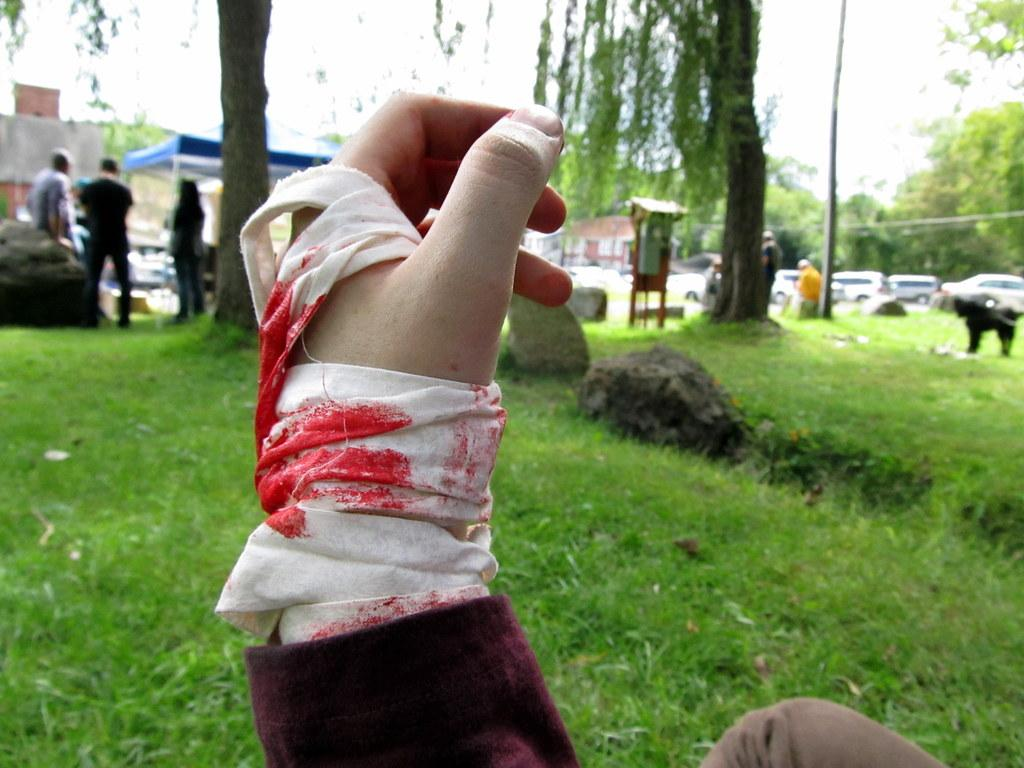What type of natural environment is visible in the image? There is grass in the image, which suggests a natural environment. What else can be seen in the image besides the grass? A: There are vehicles, people, trees, buildings, and rocks visible in the image. Can you describe the background of the image? The background of the image includes trees, buildings, and a dog. What might be used for sitting or climbing in the image? The rocks visible in the image might be used for sitting or climbing. What direction is the bell pointing in the image? There is no bell present in the image. What type of work are the people in the image engaged in? The image does not provide any information about the work the people might be engaged in. 